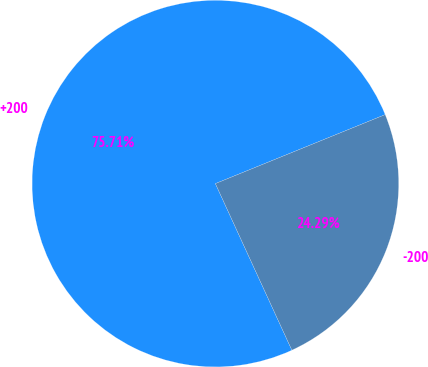<chart> <loc_0><loc_0><loc_500><loc_500><pie_chart><fcel>+200<fcel>-200<nl><fcel>75.71%<fcel>24.29%<nl></chart> 